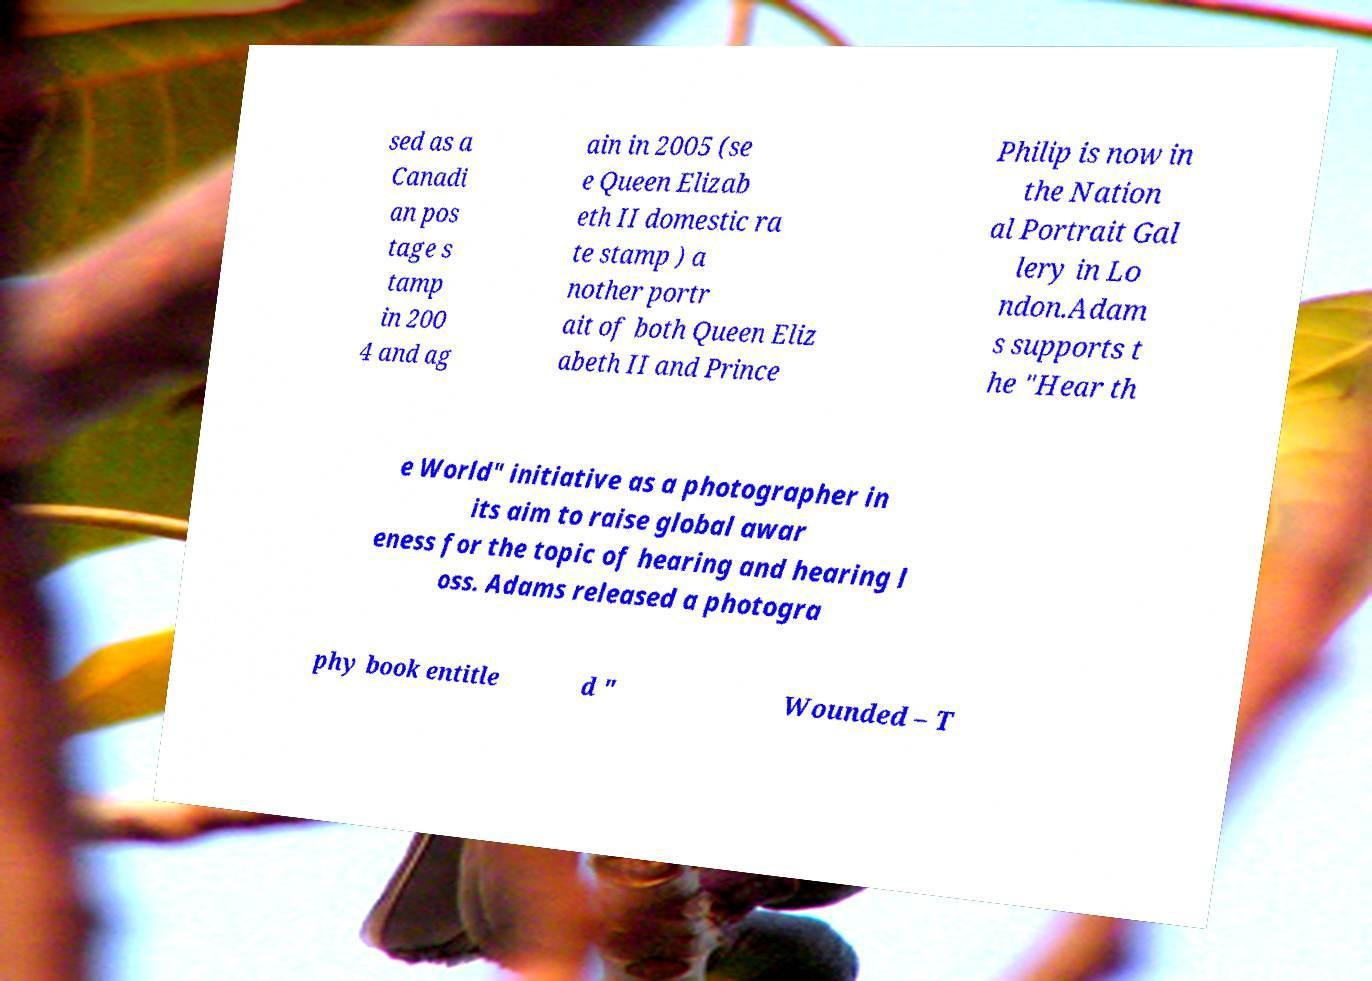I need the written content from this picture converted into text. Can you do that? sed as a Canadi an pos tage s tamp in 200 4 and ag ain in 2005 (se e Queen Elizab eth II domestic ra te stamp ) a nother portr ait of both Queen Eliz abeth II and Prince Philip is now in the Nation al Portrait Gal lery in Lo ndon.Adam s supports t he "Hear th e World" initiative as a photographer in its aim to raise global awar eness for the topic of hearing and hearing l oss. Adams released a photogra phy book entitle d " Wounded – T 